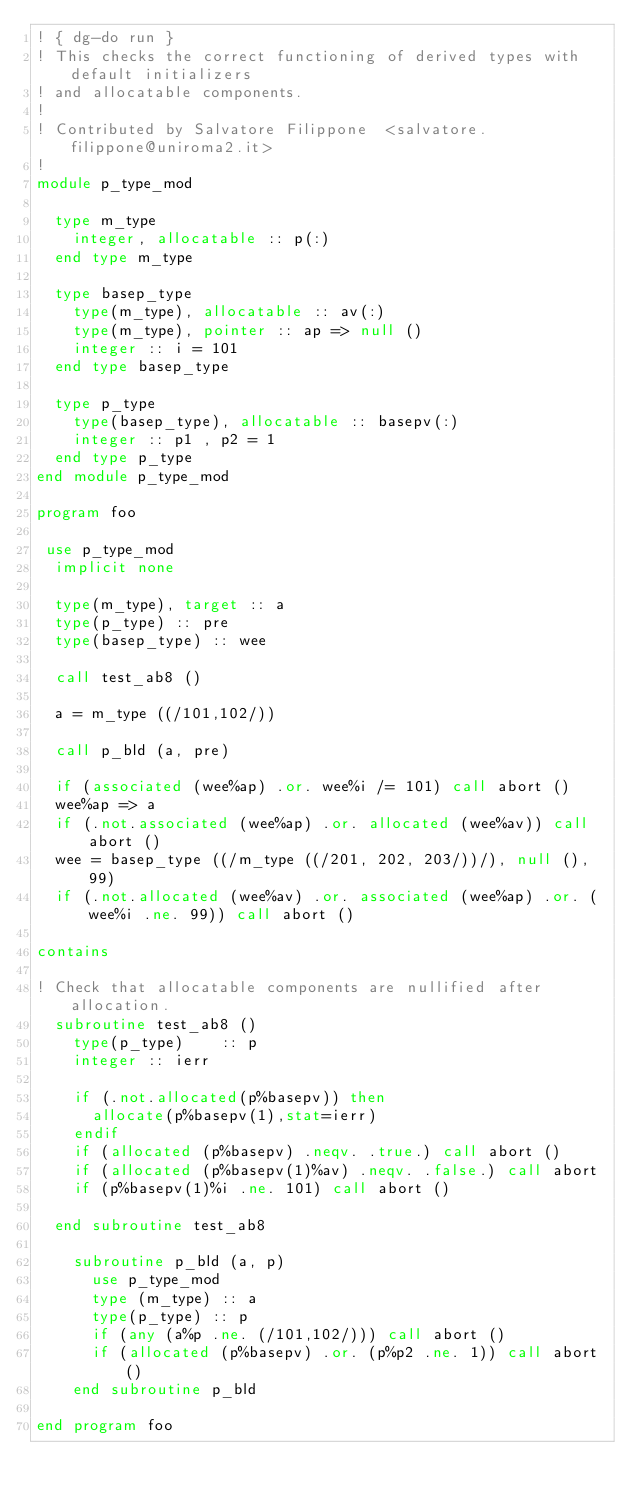<code> <loc_0><loc_0><loc_500><loc_500><_FORTRAN_>! { dg-do run }
! This checks the correct functioning of derived types with default initializers
! and allocatable components.
!
! Contributed by Salvatore Filippone  <salvatore.filippone@uniroma2.it>
!
module p_type_mod

  type m_type
    integer, allocatable :: p(:)
  end type m_type

  type basep_type
    type(m_type), allocatable :: av(:)
    type(m_type), pointer :: ap => null ()
    integer :: i = 101
  end type basep_type

  type p_type
    type(basep_type), allocatable :: basepv(:)
    integer :: p1 , p2 = 1
  end type p_type
end module p_type_mod

program foo
 
 use p_type_mod
  implicit none

  type(m_type), target :: a
  type(p_type) :: pre
  type(basep_type) :: wee

  call test_ab8 ()

  a = m_type ((/101,102/))  

  call p_bld (a, pre)

  if (associated (wee%ap) .or. wee%i /= 101) call abort ()
  wee%ap => a
  if (.not.associated (wee%ap) .or. allocated (wee%av)) call abort ()
  wee = basep_type ((/m_type ((/201, 202, 203/))/), null (), 99)
  if (.not.allocated (wee%av) .or. associated (wee%ap) .or. (wee%i .ne. 99)) call abort () 

contains

! Check that allocatable components are nullified after allocation.
  subroutine test_ab8 ()
    type(p_type)    :: p
    integer :: ierr
  
    if (.not.allocated(p%basepv)) then 
      allocate(p%basepv(1),stat=ierr)
    endif
    if (allocated (p%basepv) .neqv. .true.) call abort ()
    if (allocated (p%basepv(1)%av) .neqv. .false.) call abort
    if (p%basepv(1)%i .ne. 101) call abort ()

  end subroutine test_ab8

    subroutine p_bld (a, p)
      use p_type_mod
      type (m_type) :: a
      type(p_type) :: p
      if (any (a%p .ne. (/101,102/))) call abort ()
      if (allocated (p%basepv) .or. (p%p2 .ne. 1)) call abort ()
    end subroutine p_bld

end program foo
</code> 